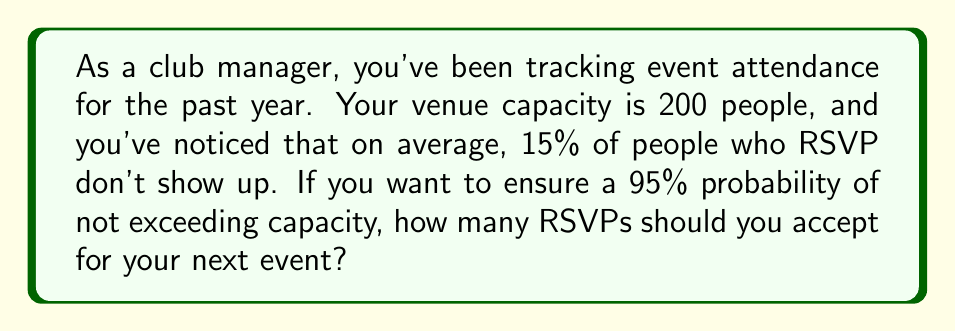Show me your answer to this math problem. Let's approach this step-by-step:

1) Let $x$ be the number of RSVPs we accept.

2) The number of people who actually show up follows a binomial distribution with probability $p = 0.85$ (since 15% don't show up, 85% do show up).

3) We want the probability of 200 or fewer people showing up to be at least 0.95.

4) This can be expressed as:

   $P(X \leq 200) \geq 0.95$, where $X \sim B(x, 0.85)$

5) We can approximate this binomial distribution with a normal distribution when $xp$ and $x(1-p)$ are both greater than 5.

6) The normal approximation has mean $\mu = xp = 0.85x$ and standard deviation $\sigma = \sqrt{xp(1-p)} = \sqrt{0.85 \cdot 0.15x} = \sqrt{0.1275x}$

7) Using the z-score formula:

   $z = \frac{200.5 - 0.85x}{\sqrt{0.1275x}} \geq 1.645$  (we use 200.5 for continuity correction)

8) Solving this inequality:

   $\frac{200.5 - 0.85x}{\sqrt{0.1275x}} \geq 1.645$
   $200.5 - 0.85x \geq 1.645\sqrt{0.1275x}$
   $(200.5 - 0.85x)^2 \geq (1.645\sqrt{0.1275x})^2$
   $40200.25 - 340.85x + 0.7225x^2 \geq 0.3453x$
   $0.7225x^2 - 341.1953x + 40200.25 \geq 0$

9) Solving this quadratic inequality gives us $x \leq 235.29$

10) Since we need an integer number of RSVPs, we round down to 235.
Answer: 235 RSVPs 